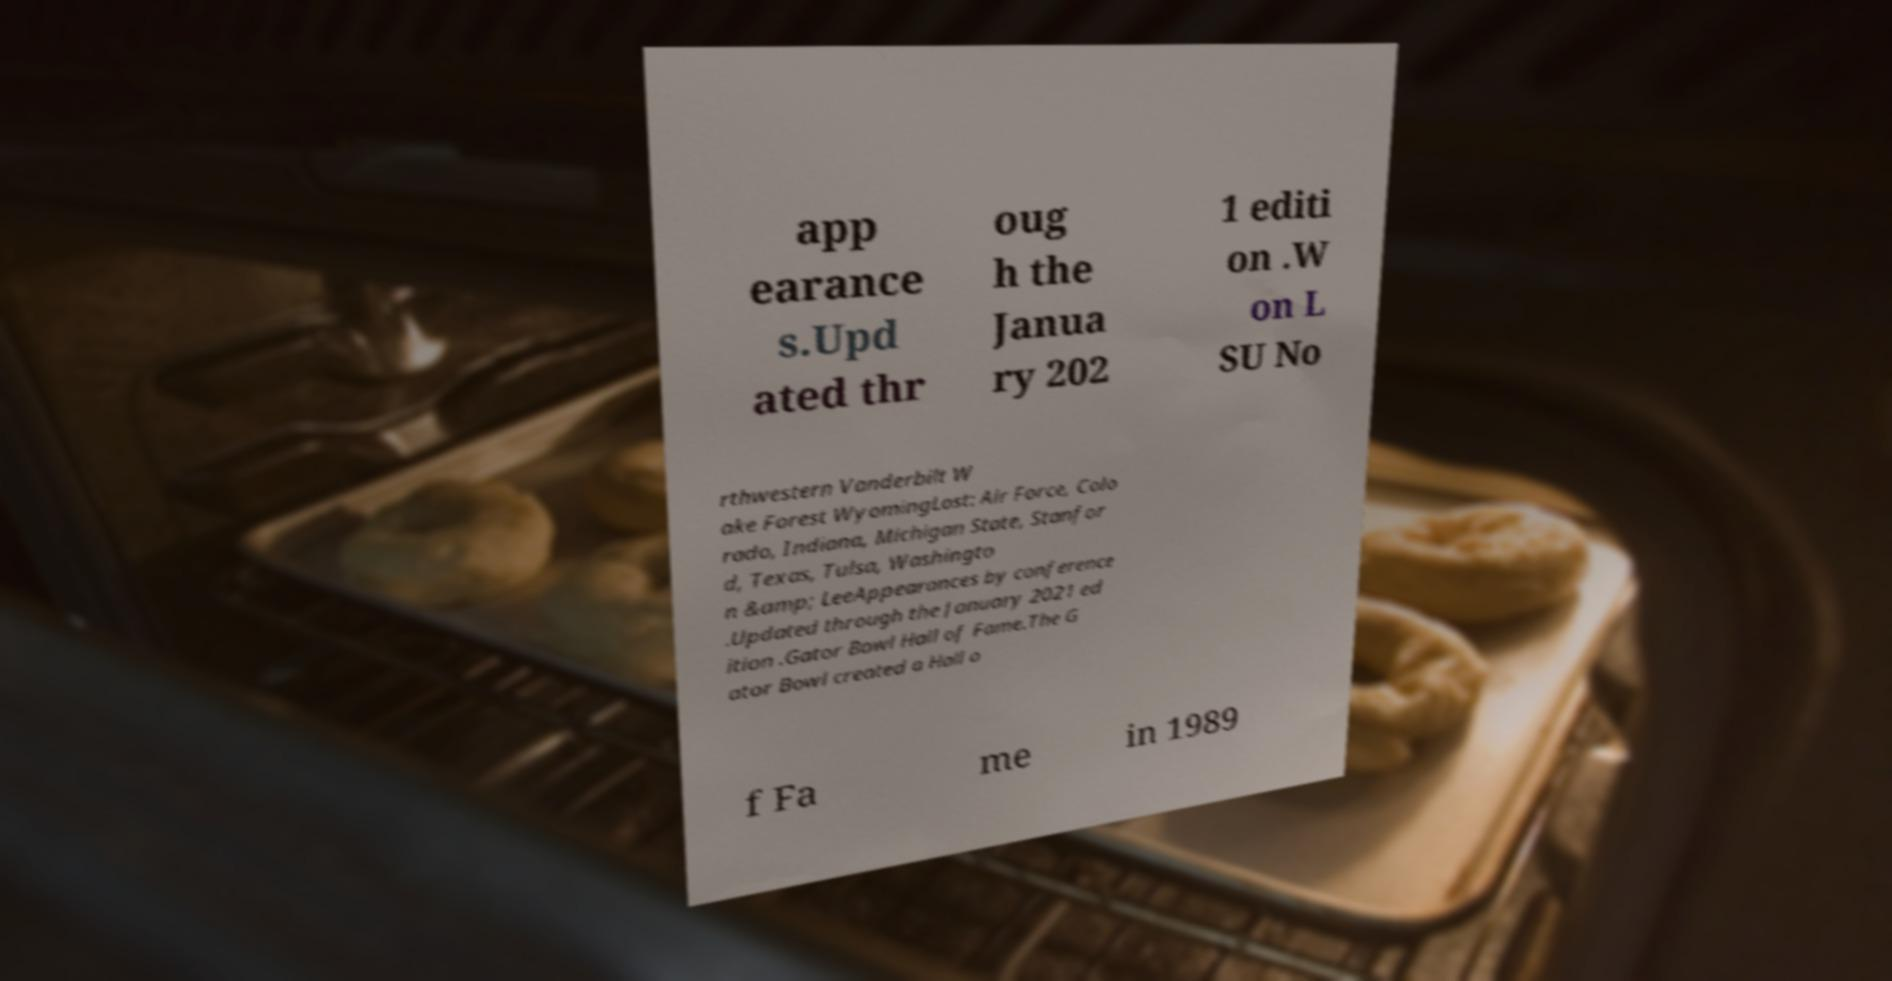Could you assist in decoding the text presented in this image and type it out clearly? app earance s.Upd ated thr oug h the Janua ry 202 1 editi on .W on L SU No rthwestern Vanderbilt W ake Forest WyomingLost: Air Force, Colo rado, Indiana, Michigan State, Stanfor d, Texas, Tulsa, Washingto n &amp; LeeAppearances by conference .Updated through the January 2021 ed ition .Gator Bowl Hall of Fame.The G ator Bowl created a Hall o f Fa me in 1989 